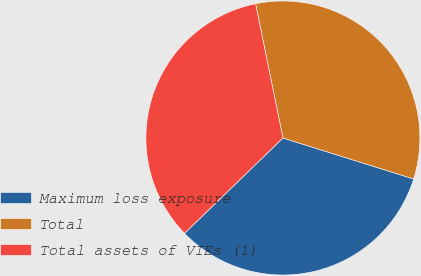Convert chart to OTSL. <chart><loc_0><loc_0><loc_500><loc_500><pie_chart><fcel>Maximum loss exposure<fcel>Total<fcel>Total assets of VIEs (1)<nl><fcel>32.92%<fcel>33.03%<fcel>34.05%<nl></chart> 